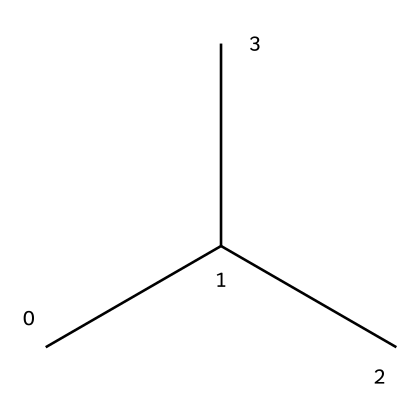What type of polymer does this SMILES structure represent? The chemical structure CC(C)C implies that it is a polymer made from repeating units of the alkene ethylene (C2H4), which is commonly used to create polyethylene. As it shows branching, it indicates a low-density polyethylene.
Answer: polyethylene How many carbon atoms are present in this structure? The SMILES CC(C)C indicates that there are four carbon atoms in total: one central carbon (C) with two other carbon branches (C) and one terminal carbon (C).
Answer: four What is the molecular formula for this compound? By counting the carbon atoms (C) and considering the hydrogen atoms, this structure has 4 carbon atoms and 10 hydrogen atoms, leading to the molecular formula C4H10.
Answer: C4H10 What type of bonding is primarily present in this molecule? The structure contains only single bonds between carbon atoms, which indicates that it primarily features covalent bonding characteristic of alkanes.
Answer: covalent How does branching affect the properties of this polyethylene? The presence of branching, as indicated by the structure CC(C)C, provides the polyethylene with more flexibility and lowers its density compared to linear polyethylene, affecting its mechanical properties.
Answer: flexibility What is the primary use of polyethylene derived from this structure in soccer cleats? Polyethylene's main purpose in soccer cleats is to provide a lightweight, flexible, and durable material for various components, enhancing performance and comfort during play.
Answer: lightweight 